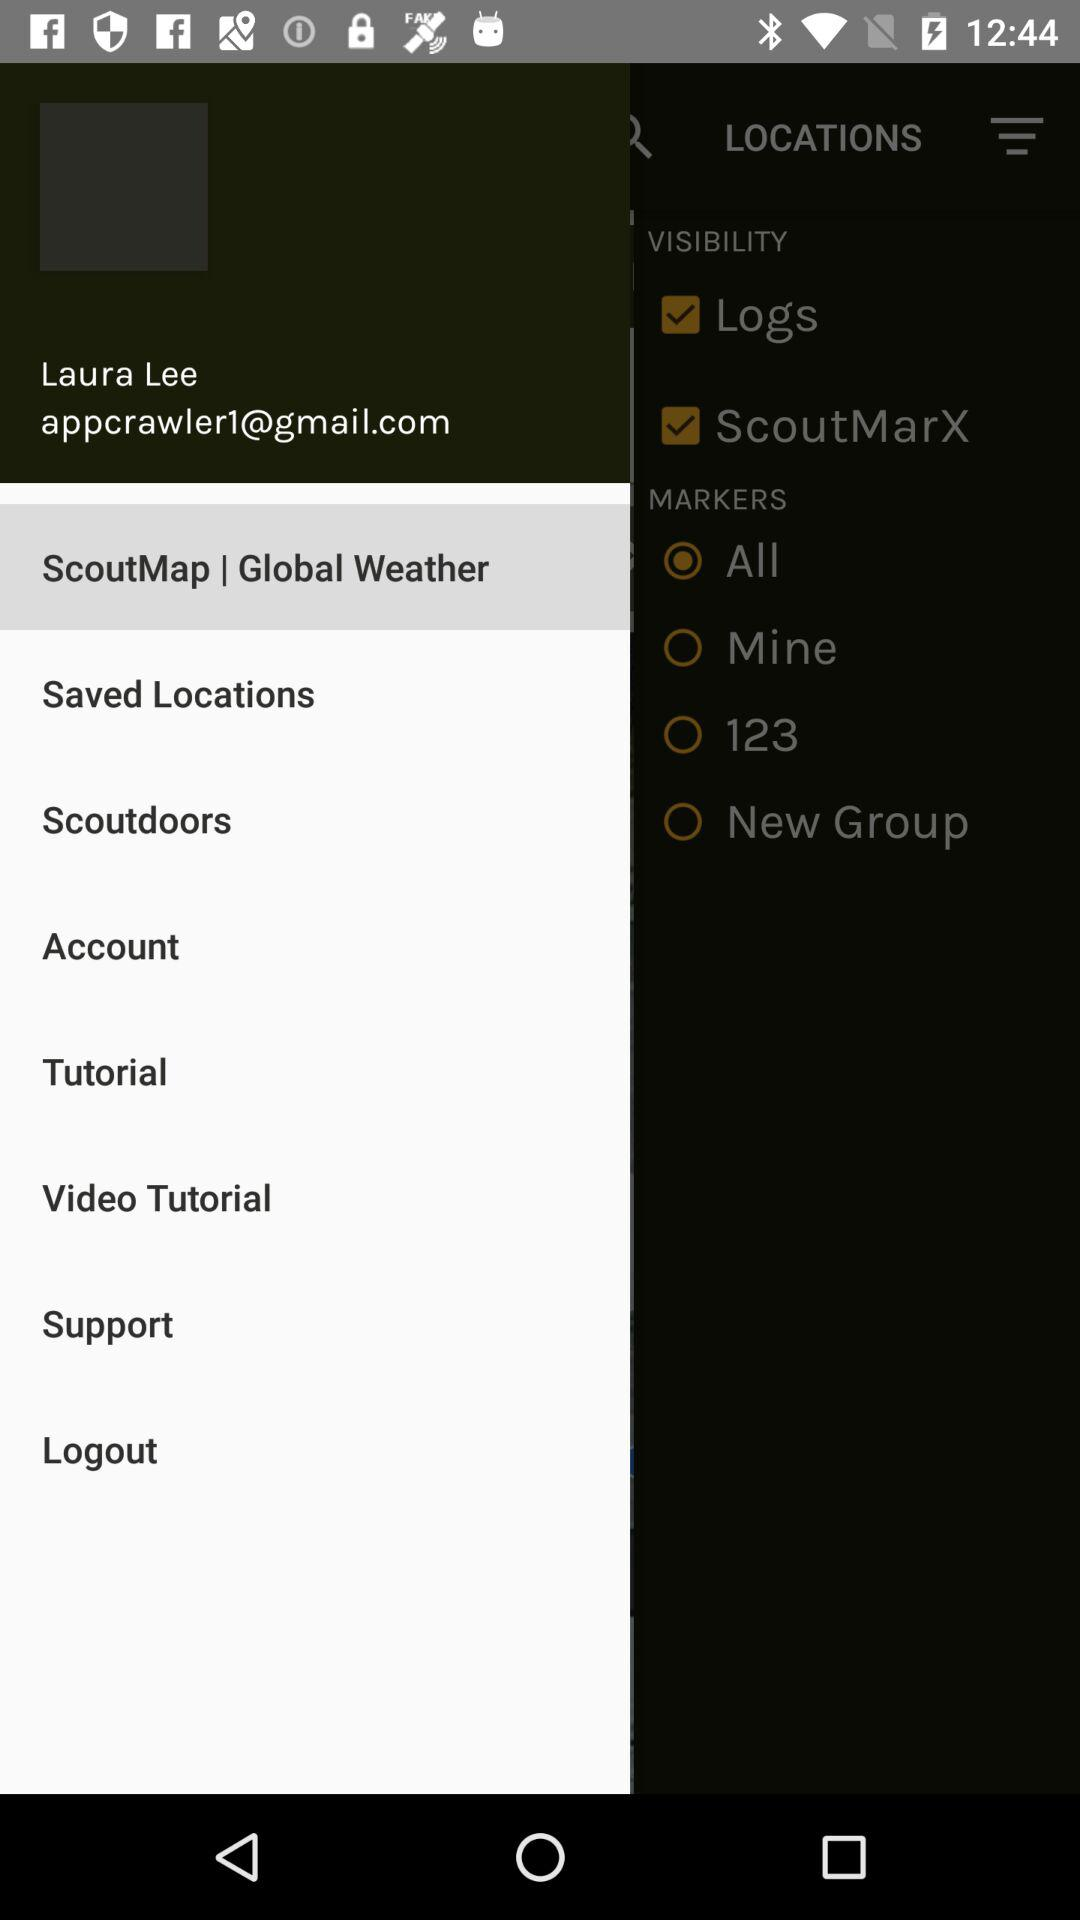What is the name of the user? The name of the user is Laura Lee. 